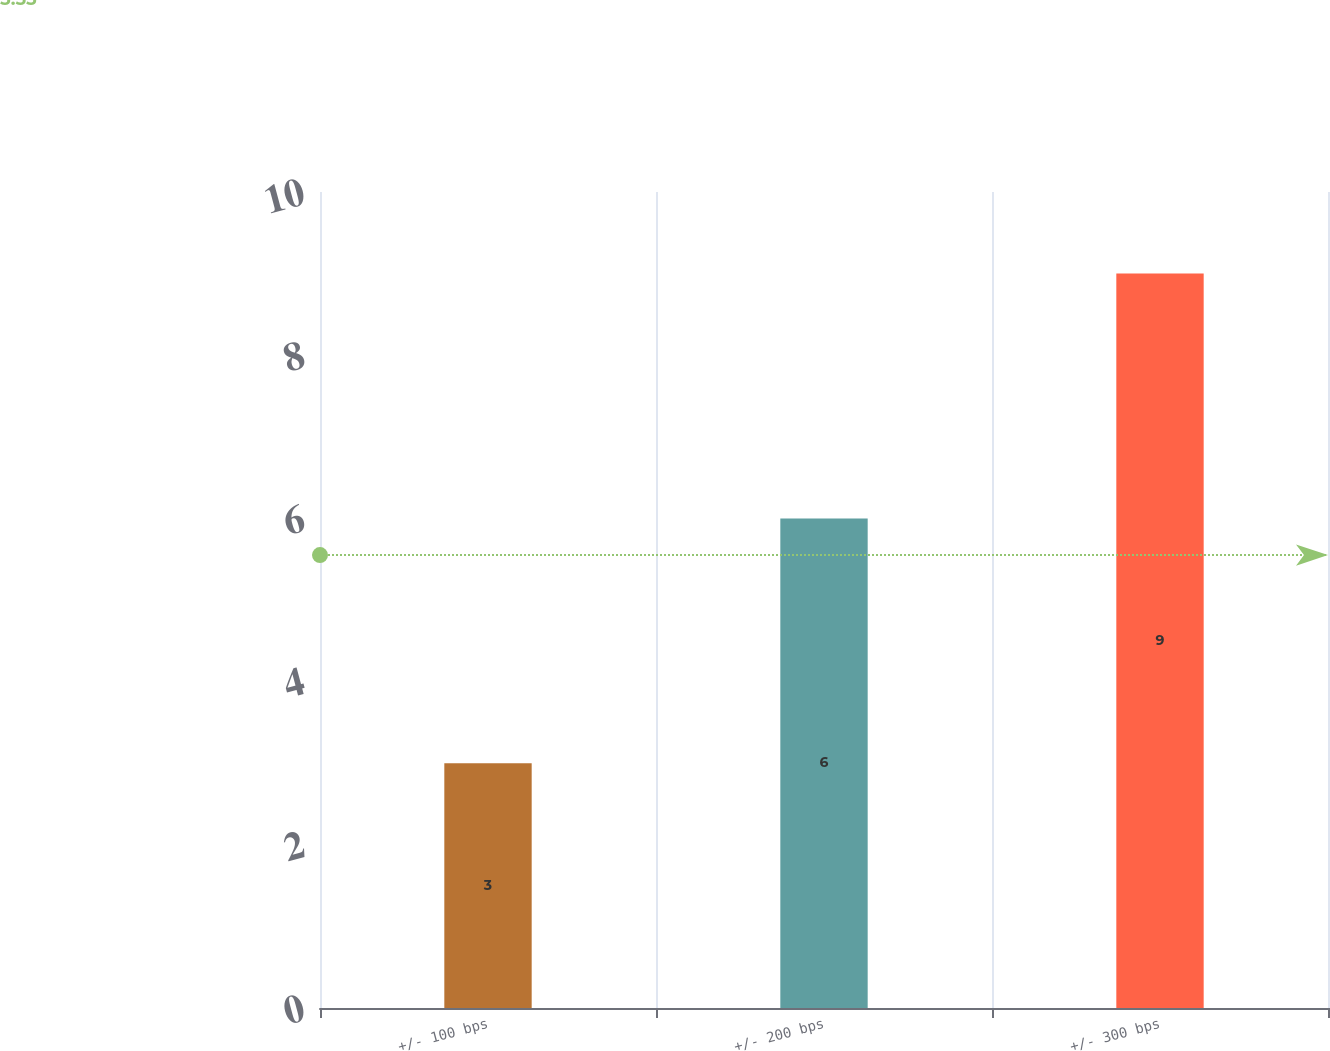Convert chart. <chart><loc_0><loc_0><loc_500><loc_500><bar_chart><fcel>+/- 100 bps<fcel>+/- 200 bps<fcel>+/- 300 bps<nl><fcel>3<fcel>6<fcel>9<nl></chart> 